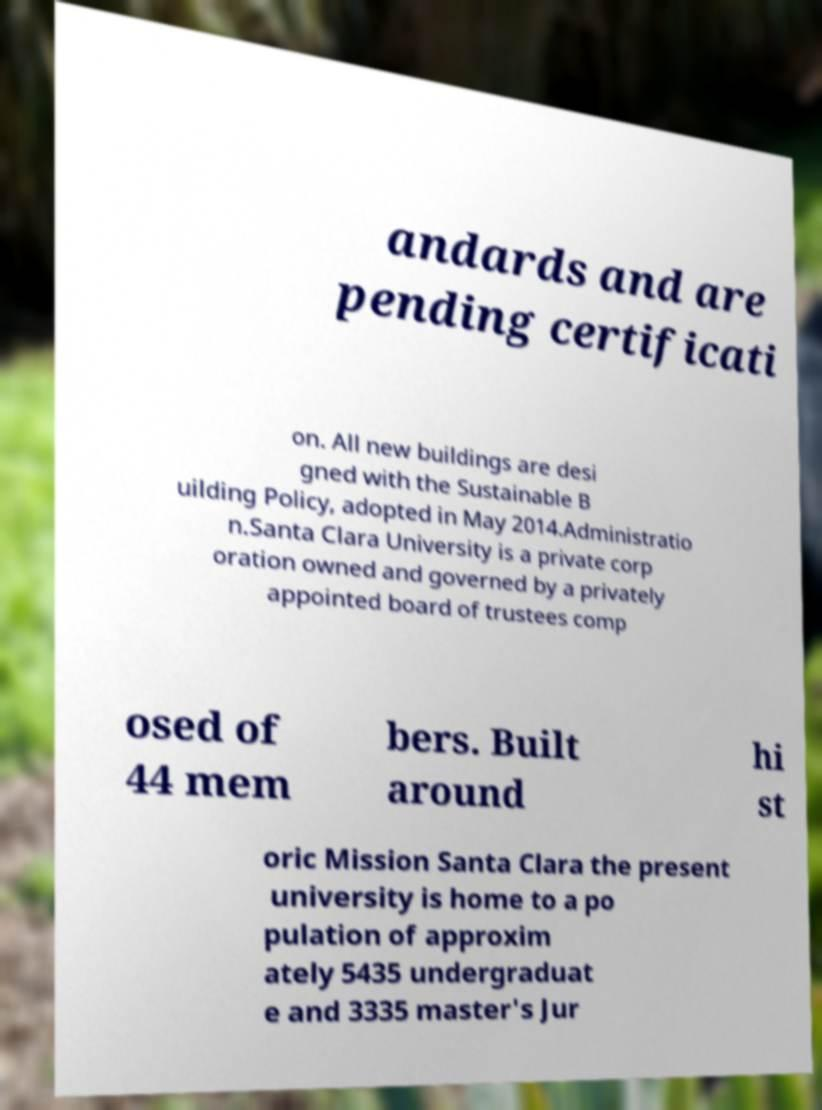Please read and relay the text visible in this image. What does it say? andards and are pending certificati on. All new buildings are desi gned with the Sustainable B uilding Policy, adopted in May 2014.Administratio n.Santa Clara University is a private corp oration owned and governed by a privately appointed board of trustees comp osed of 44 mem bers. Built around hi st oric Mission Santa Clara the present university is home to a po pulation of approxim ately 5435 undergraduat e and 3335 master's Jur 